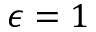Convert formula to latex. <formula><loc_0><loc_0><loc_500><loc_500>\epsilon = 1</formula> 